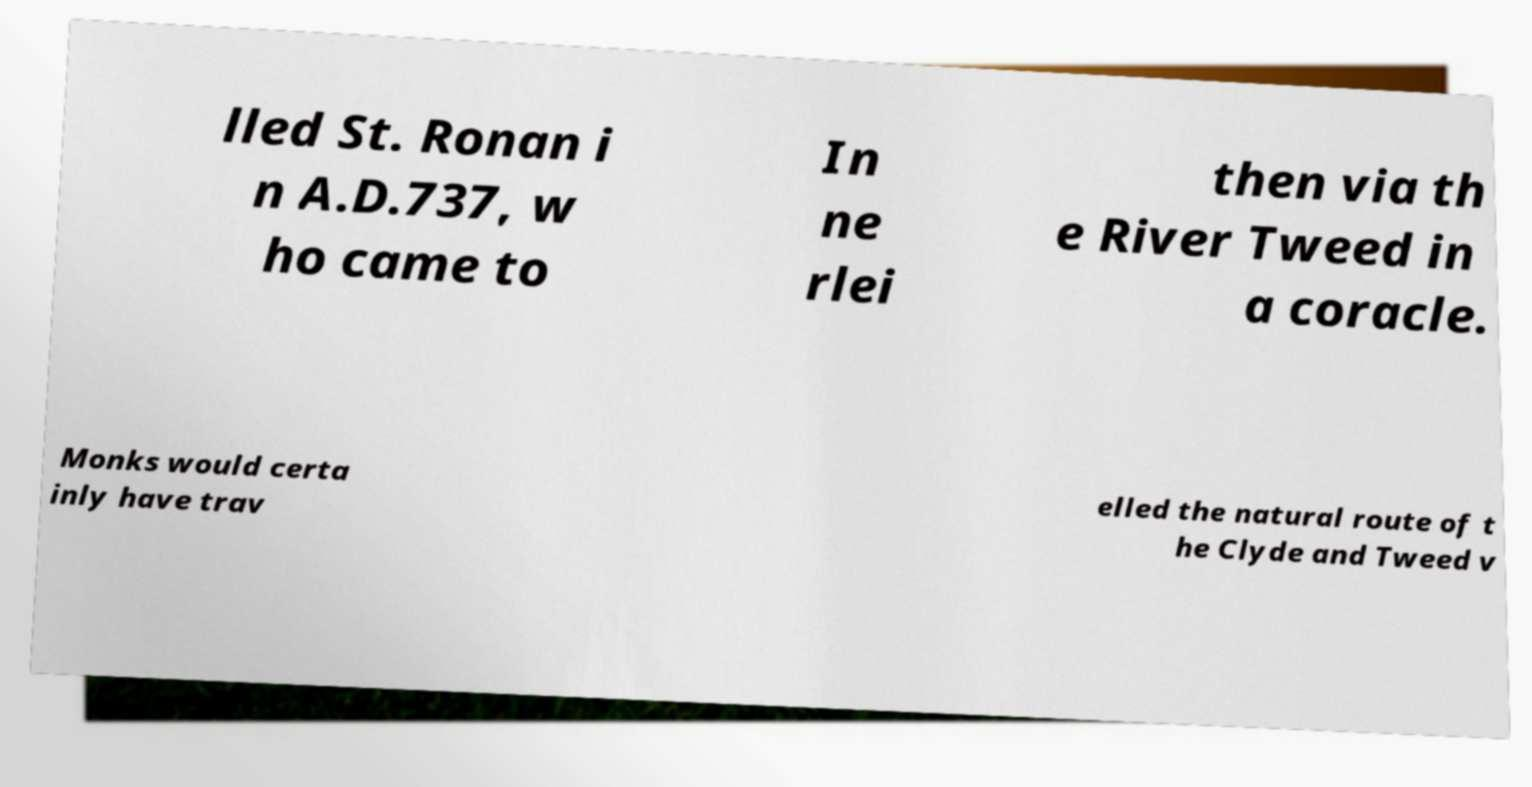I need the written content from this picture converted into text. Can you do that? lled St. Ronan i n A.D.737, w ho came to In ne rlei then via th e River Tweed in a coracle. Monks would certa inly have trav elled the natural route of t he Clyde and Tweed v 